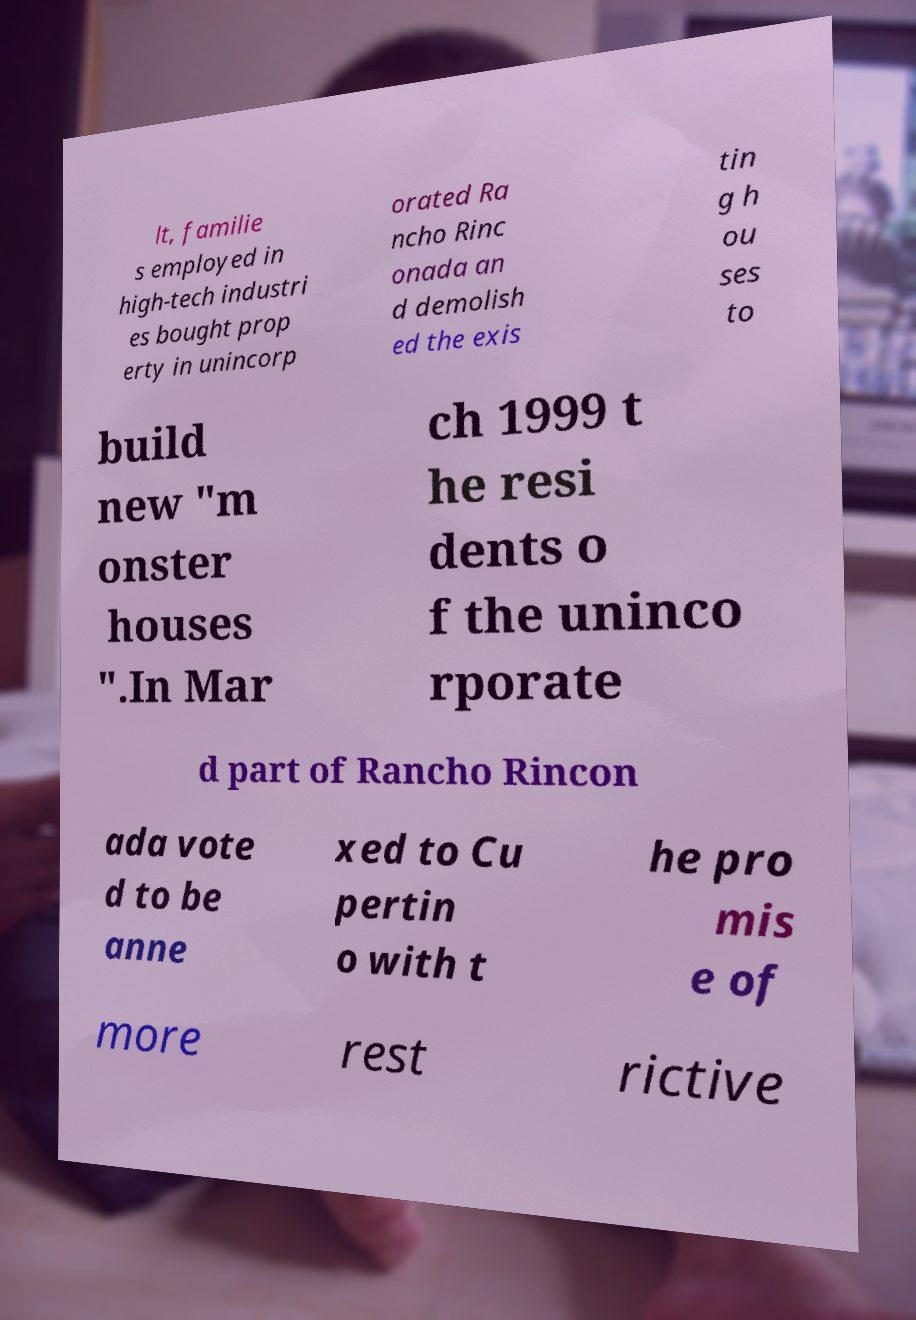What messages or text are displayed in this image? I need them in a readable, typed format. lt, familie s employed in high-tech industri es bought prop erty in unincorp orated Ra ncho Rinc onada an d demolish ed the exis tin g h ou ses to build new "m onster houses ".In Mar ch 1999 t he resi dents o f the uninco rporate d part of Rancho Rincon ada vote d to be anne xed to Cu pertin o with t he pro mis e of more rest rictive 